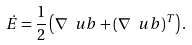Convert formula to latex. <formula><loc_0><loc_0><loc_500><loc_500>\dot { E } = \frac { 1 } { 2 } \left ( \nabla \ u b + ( \nabla \ u b ) ^ { T } \right ) .</formula> 